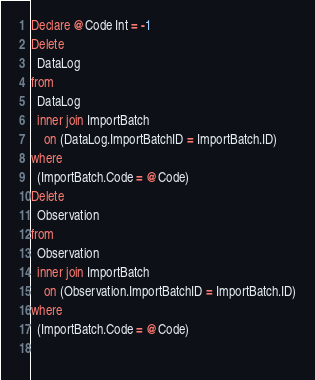Convert code to text. <code><loc_0><loc_0><loc_500><loc_500><_SQL_>Declare @Code Int = -1
Delete
  DataLog
from
  DataLog
  inner join ImportBatch
    on (DataLog.ImportBatchID = ImportBatch.ID)
where
  (ImportBatch.Code = @Code)
Delete
  Observation
from
  Observation
  inner join ImportBatch
    on (Observation.ImportBatchID = ImportBatch.ID)
where
  (ImportBatch.Code = @Code)
    </code> 